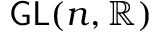<formula> <loc_0><loc_0><loc_500><loc_500>G L ( n , \mathbb { R } )</formula> 